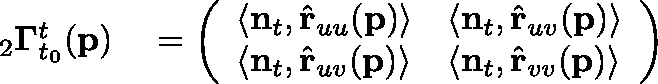<formula> <loc_0><loc_0><loc_500><loc_500>\begin{array} { r l } _ { 2 } \Gamma _ { t _ { 0 } } ^ { t } ( p ) } & = \left ( \begin{array} { l l } { \langle n _ { t } , \hat { r } _ { u u } ( p ) \rangle } & { \langle n _ { t } , \hat { r } _ { u v } ( p ) \rangle } \\ { \langle n _ { t } , \hat { r } _ { u v } ( p ) \rangle } & { \langle n _ { t } , \hat { r } _ { v v } ( p ) \rangle } \end{array} \right ) } \end{array}</formula> 